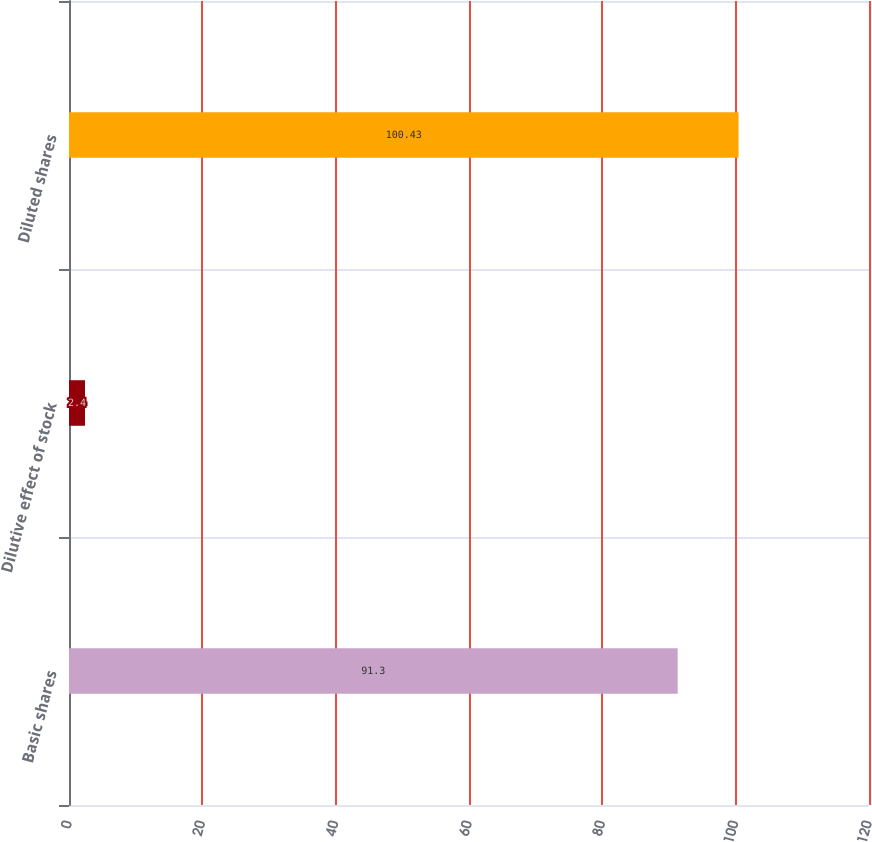Convert chart. <chart><loc_0><loc_0><loc_500><loc_500><bar_chart><fcel>Basic shares<fcel>Dilutive effect of stock<fcel>Diluted shares<nl><fcel>91.3<fcel>2.4<fcel>100.43<nl></chart> 